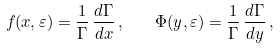Convert formula to latex. <formula><loc_0><loc_0><loc_500><loc_500>f ( x , \varepsilon ) = \frac { 1 } { \Gamma } \, \frac { { d } \Gamma } { { d } x } \, , \quad \Phi ( y , \varepsilon ) = \frac { 1 } { \Gamma } \, \frac { { d } \Gamma } { { d } y } \, ,</formula> 